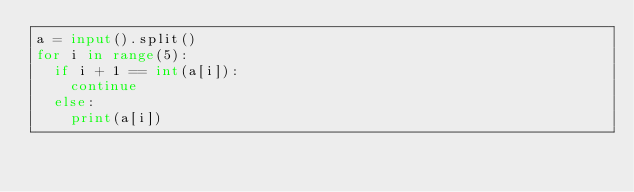<code> <loc_0><loc_0><loc_500><loc_500><_Python_>a = input().split()
for i in range(5):
  if i + 1 == int(a[i]):
    continue
  else:
    print(a[i])
</code> 